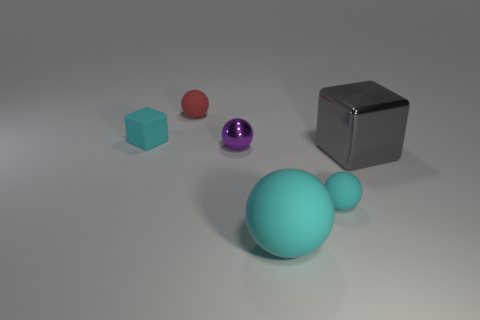Can you describe the lighting and any shadows present in this scenario? The lighting in the image is subtle and appears to be coming from above, at a slight angle, given the direction of the shadows. Each object casts a soft shadow directly opposite the light source, suggesting a diffused lighting environment that's likely indoors. The shadows are consistent with an overhead, possibly singular, light source. 